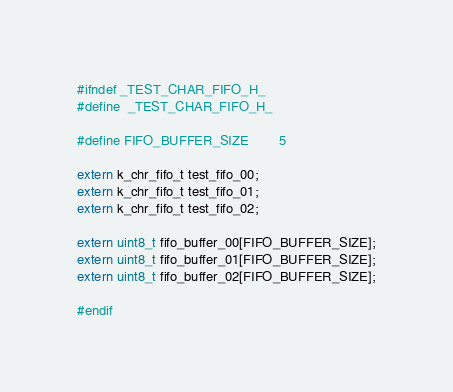Convert code to text. <code><loc_0><loc_0><loc_500><loc_500><_C_>#ifndef _TEST_CHAR_FIFO_H_
#define  _TEST_CHAR_FIFO_H_

#define FIFO_BUFFER_SIZE        5

extern k_chr_fifo_t test_fifo_00;
extern k_chr_fifo_t test_fifo_01;
extern k_chr_fifo_t test_fifo_02;

extern uint8_t fifo_buffer_00[FIFO_BUFFER_SIZE];
extern uint8_t fifo_buffer_01[FIFO_BUFFER_SIZE];
extern uint8_t fifo_buffer_02[FIFO_BUFFER_SIZE];

#endif

</code> 